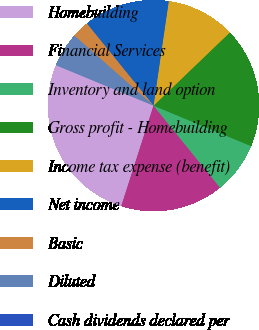Convert chart. <chart><loc_0><loc_0><loc_500><loc_500><pie_chart><fcel>Homebuilding<fcel>Financial Services<fcel>Inventory and land option<fcel>Gross profit - Homebuilding<fcel>Income tax expense (benefit)<fcel>Net income<fcel>Basic<fcel>Diluted<fcel>Cash dividends declared per<nl><fcel>26.31%<fcel>15.79%<fcel>7.9%<fcel>18.42%<fcel>10.53%<fcel>13.16%<fcel>2.63%<fcel>5.26%<fcel>0.0%<nl></chart> 